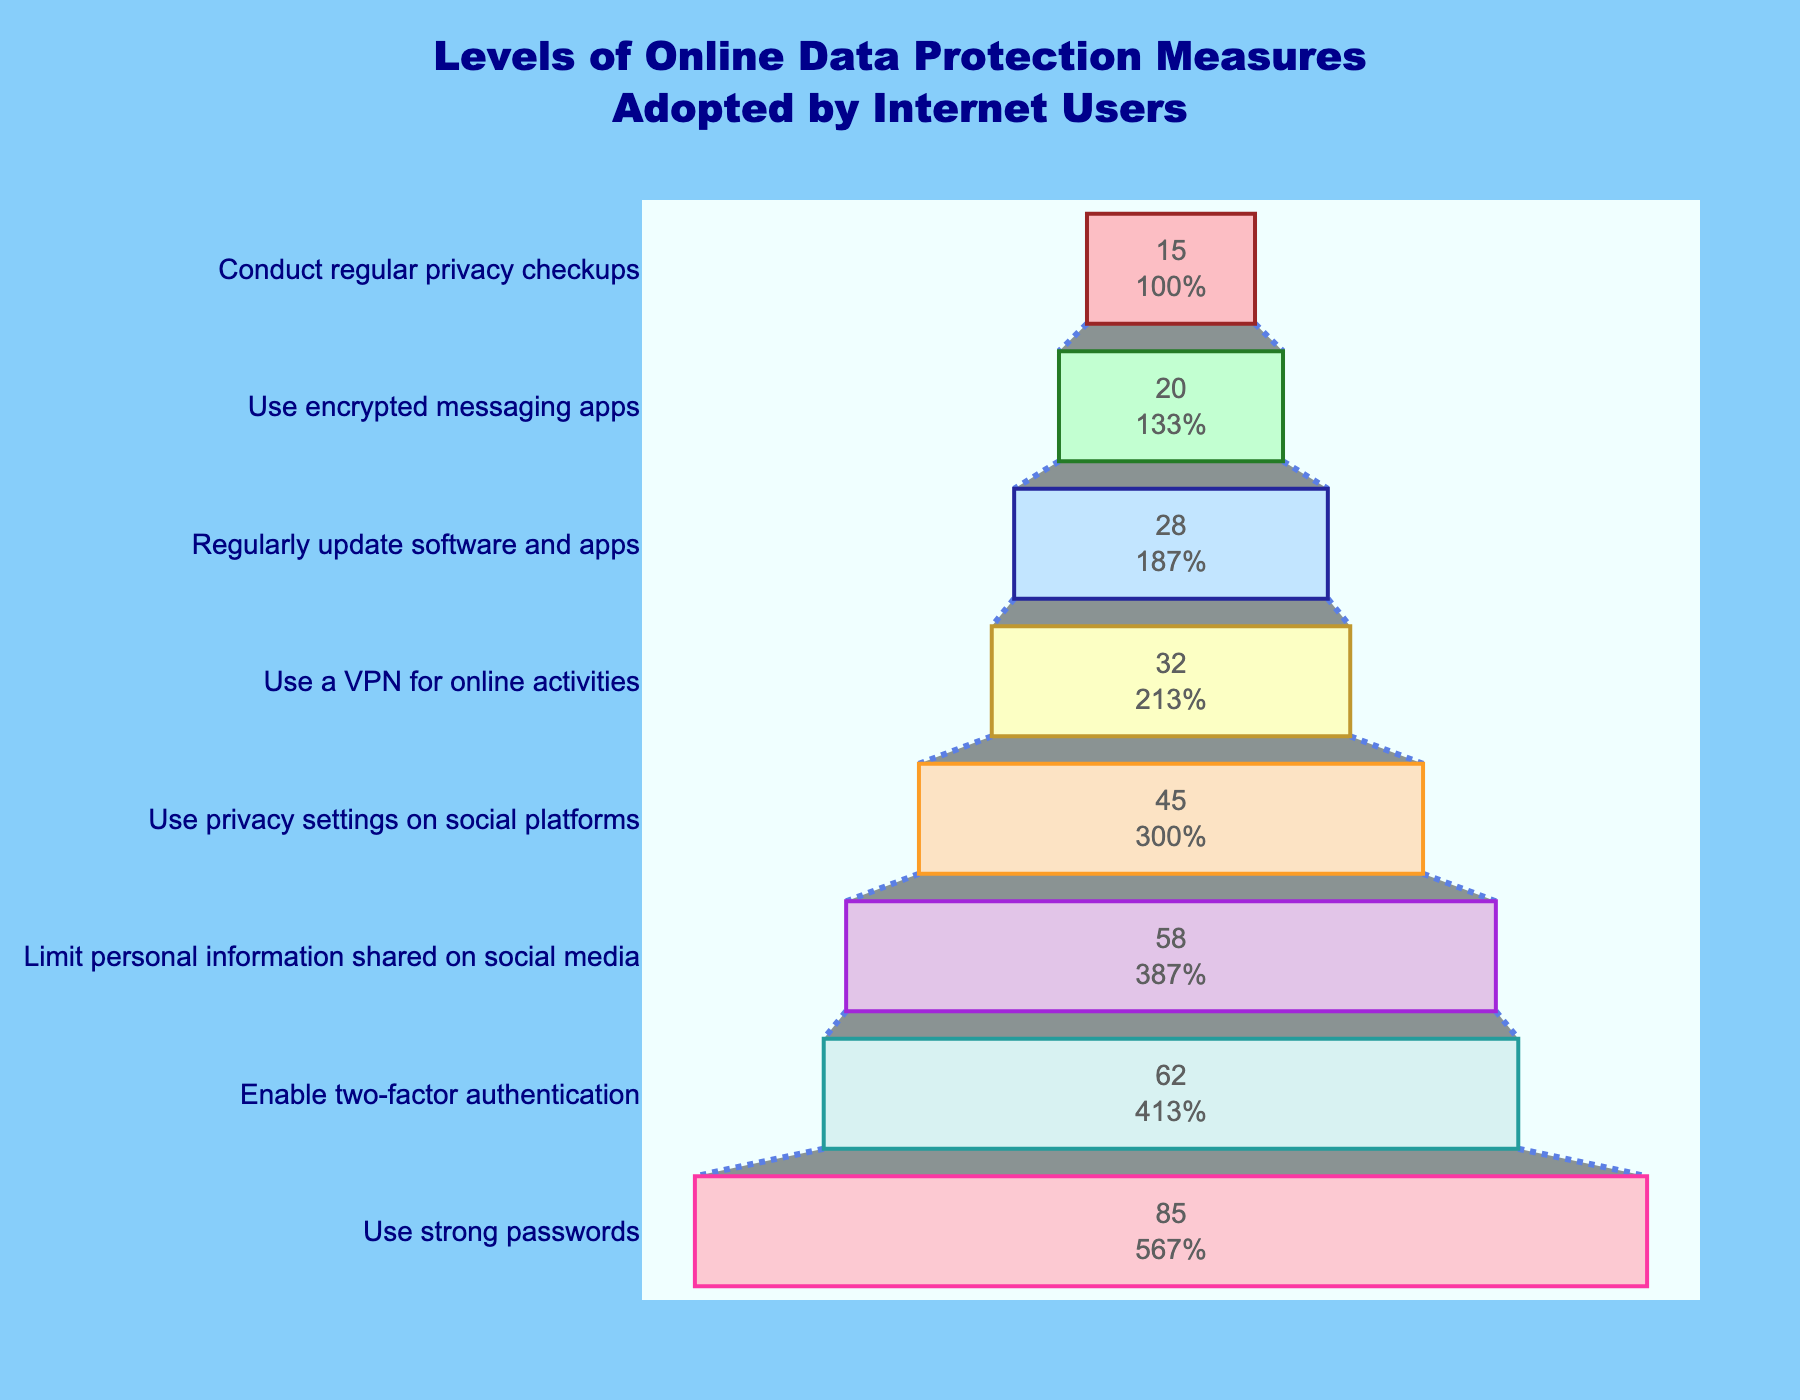What is the title of the figure? The title is prominently displayed at the top center of the figure. It reads: "Levels of Online Data Protection Measures Adopted by Internet Users."
Answer: Levels of Online Data Protection Measures Adopted by Internet Users Which data protection measure has the highest percentage of adoption? By examining the funnel chart, the widest section at the top corresponds to the highest percentage. The data protection measure "Use strong passwords" has this position with 85%.
Answer: Use strong passwords How many data protection measures are shown in the figure? The funnel chart has multiple sections, each representing a different data protection measure. Counting all the sections, we find there are eight measures in total.
Answer: 8 What percentage of users conduct regular privacy checkups? Find the corresponding section labeled "Conduct regular privacy checkups" and check the percentage displayed inside. It shows 15%.
Answer: 15% Which measure is adopted less: using a VPN for online activities or using encrypted messaging apps? Compare the percentages of the two measures mentioned. The measure "Use encrypted messaging apps" has a lower percentage at 20% compared to "Use a VPN for online activities" at 32%.
Answer: Use encrypted messaging apps What is the difference in adoption percentage between using privacy settings on social platforms and regularly updating software and apps? Locate the percentages for both measures: "Use privacy settings on social platforms" (45%) and "Regularly update software and apps" (28%). Calculate the difference: 45% - 28% = 17%.
Answer: 17% Which data protection measure has slightly more than half of the adoption rate compared to using strong passwords? Take half of the adoption rate of "Use strong passwords" (85/2 = 42.5%). Find the measure with an adoption rate slightly above 42.5%. "Use privacy settings on social platforms" at 45% fits this criterion.
Answer: Use privacy settings on social platforms What is the adoption rate of the measure that has exactly half of the percentage of enabling two-factor authentication? Enabling two-factor authentication has a percentage of 62. Half of this is 31%. The measure "Use a VPN for online activities" is the closest to this half-value, with 32%.
Answer: Use a VPN for online activities What measure has just over double the adoption percentage compared to conducting regular privacy checkups? Conducting regular privacy checkups has an adoption rate of 15%. Doubling this value gives 30%. "Use a VPN for online activities" at 32% is just over double 15%.
Answer: Use a VPN for online activities 